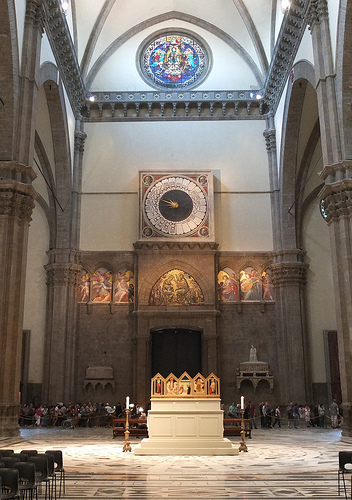What color are the chairs on the left side? The chairs on the left side are black in color. 